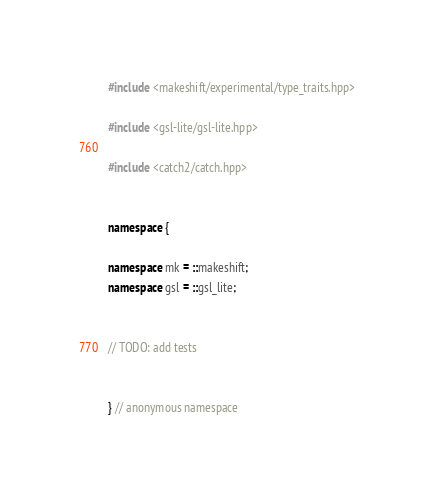Convert code to text. <code><loc_0><loc_0><loc_500><loc_500><_C++_>
#include <makeshift/experimental/type_traits.hpp>

#include <gsl-lite/gsl-lite.hpp>

#include <catch2/catch.hpp>


namespace {

namespace mk = ::makeshift;
namespace gsl = ::gsl_lite;


// TODO: add tests


} // anonymous namespace
</code> 